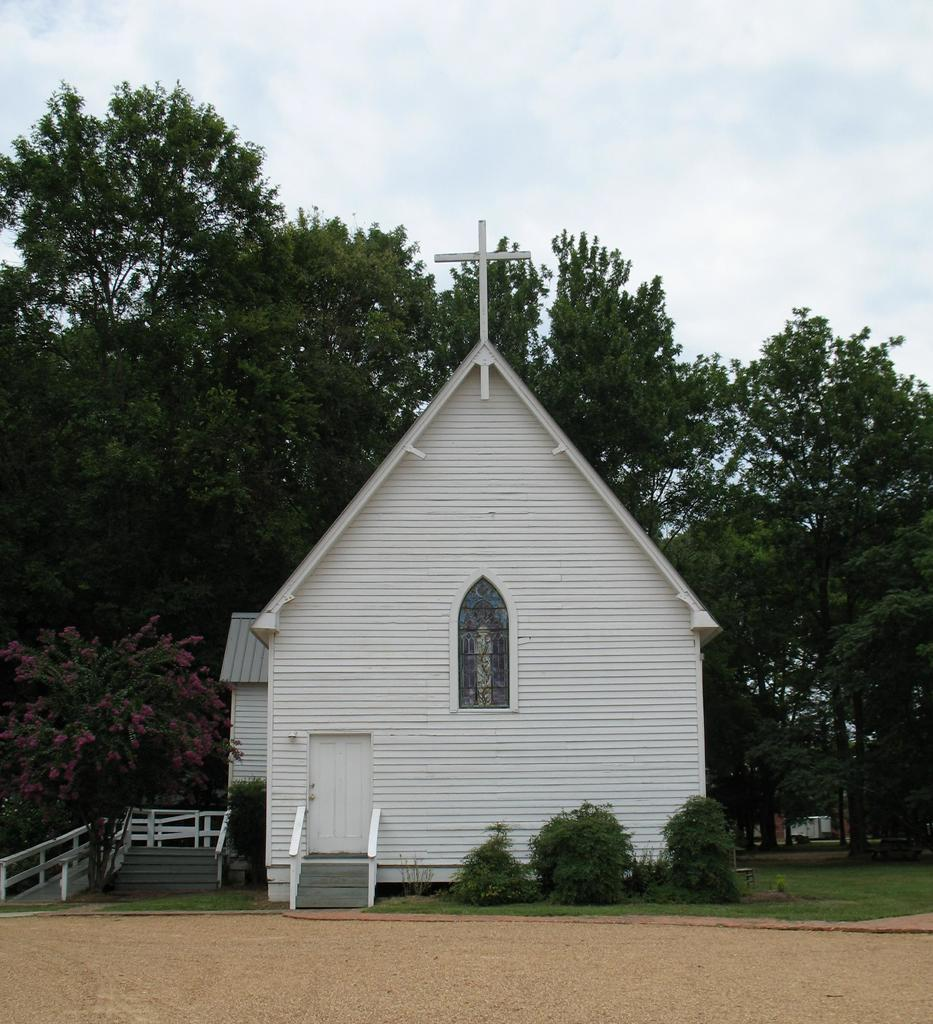What type of vegetation can be seen in the image? There are trees, plants, and grass in the image. What architectural feature is present in the image? There is a staircase in the image. What type of ground surface is visible in the image? There is soil in the image. What type of building can be seen in the image? There is a church in the image. What is the condition of the sky in the image? The sky is cloudy in the image. How many deer can be seen grazing on the grass in the image? There are no deer present in the image; it only features trees, plants, grass, a staircase, soil, a church, and a cloudy sky. What type of spoon is used to stir the clouds in the image? There is no spoon present in the image, and the clouds are not being stirred. 